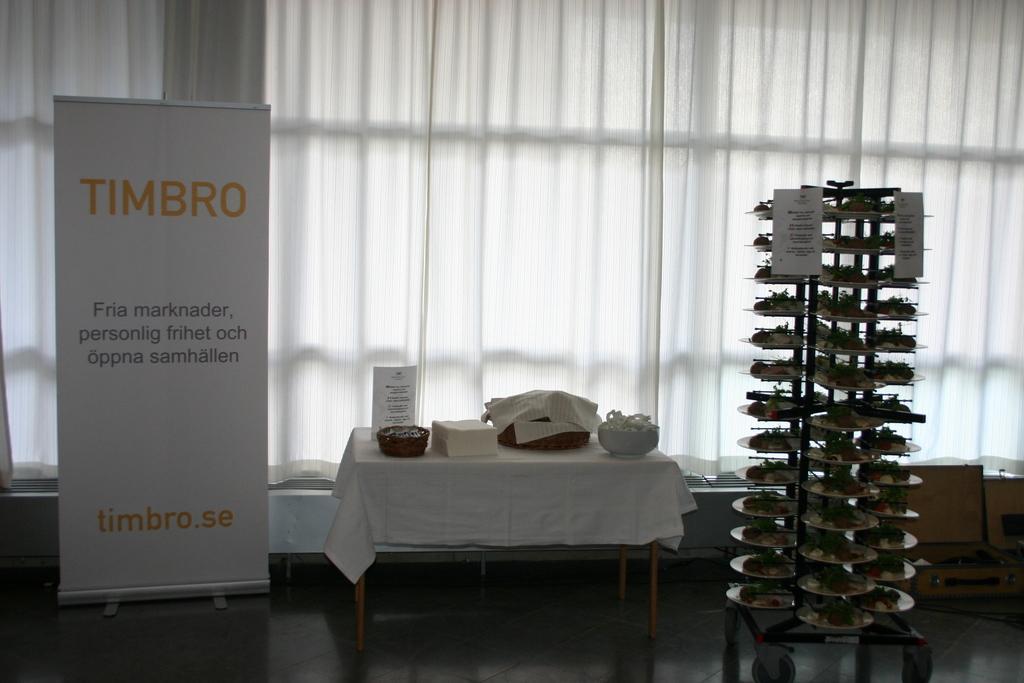Please provide a concise description of this image. In the image there is a table in the middle with cloth over it and some things and bowls on it, on the right side there is a rack with some things on it, on the left side there is a banner and behind there is curtain all over the window. 